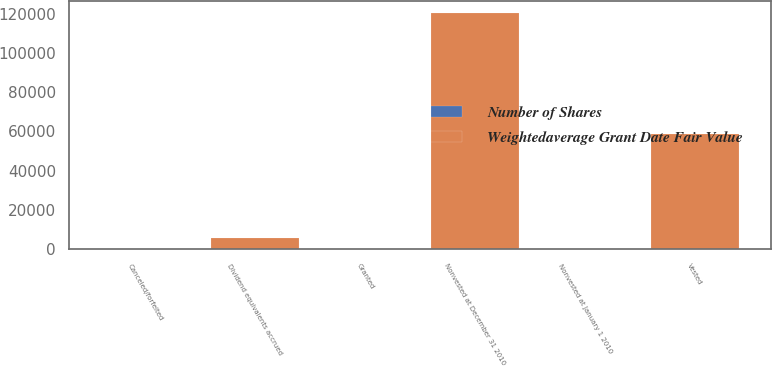Convert chart. <chart><loc_0><loc_0><loc_500><loc_500><stacked_bar_chart><ecel><fcel>Nonvested at January 1 2010<fcel>Granted<fcel>Dividend equivalents accrued<fcel>Vested<fcel>Canceled/forfeited<fcel>Nonvested at December 31 2010<nl><fcel>Weightedaverage Grant Date Fair Value<fcel>44.45<fcel>0<fcel>5686<fcel>58808<fcel>143<fcel>120237<nl><fcel>Number of Shares<fcel>43.19<fcel>0<fcel>44.77<fcel>40.54<fcel>39.49<fcel>44.45<nl></chart> 